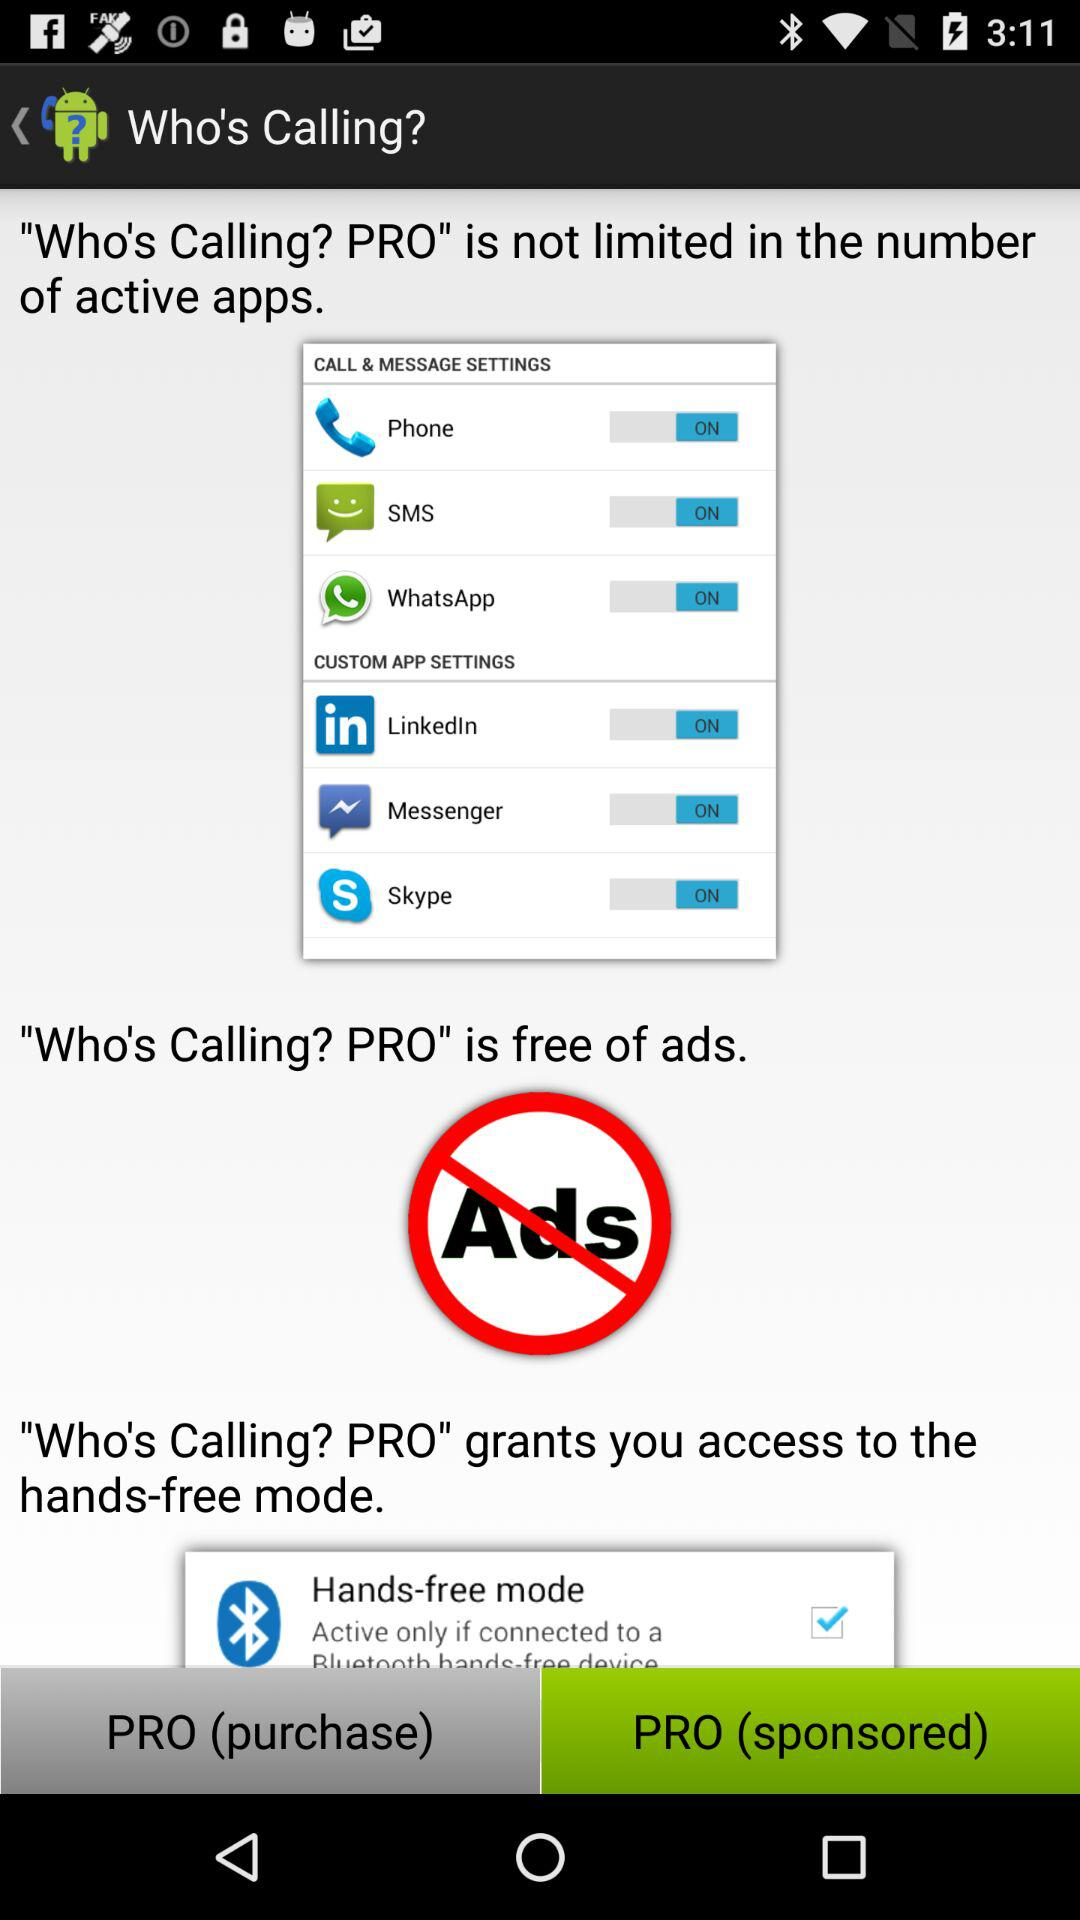How many active apps can the PRO version support?
Answer the question using a single word or phrase. Unlimited 